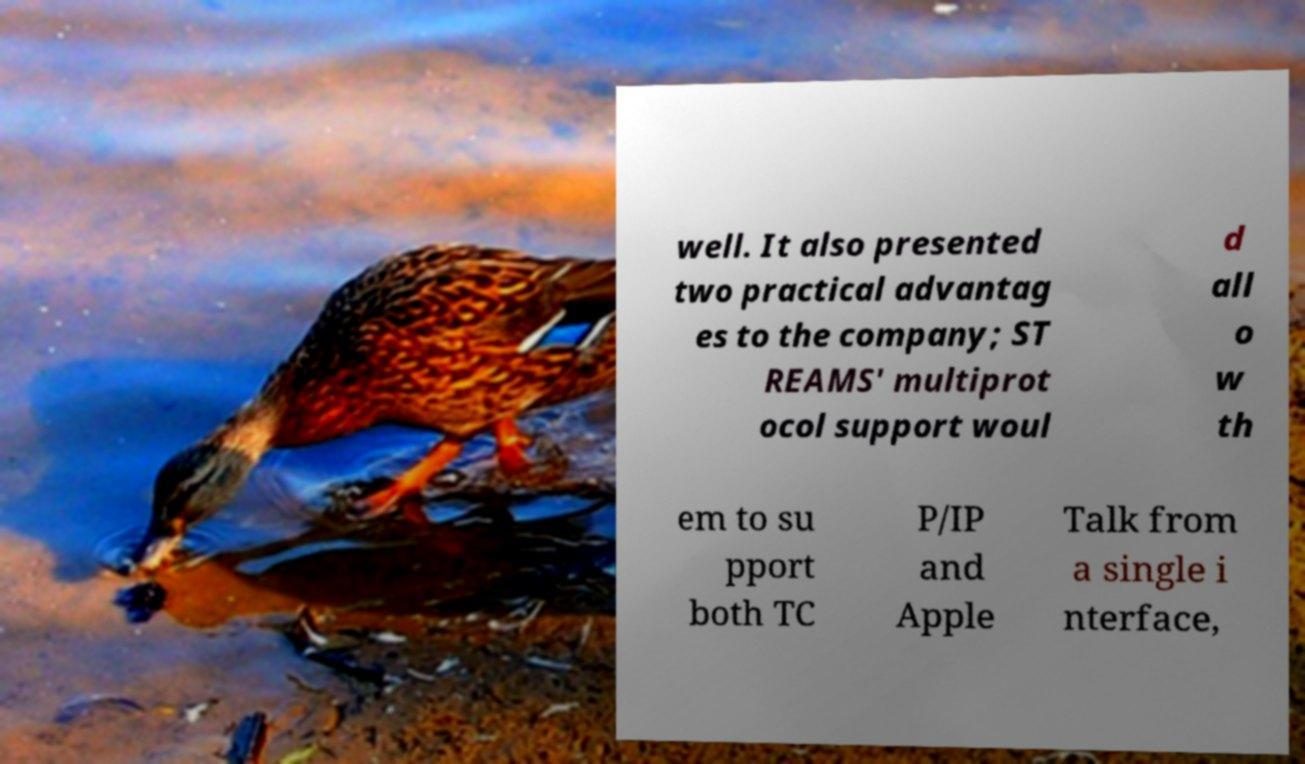Can you accurately transcribe the text from the provided image for me? well. It also presented two practical advantag es to the company; ST REAMS' multiprot ocol support woul d all o w th em to su pport both TC P/IP and Apple Talk from a single i nterface, 